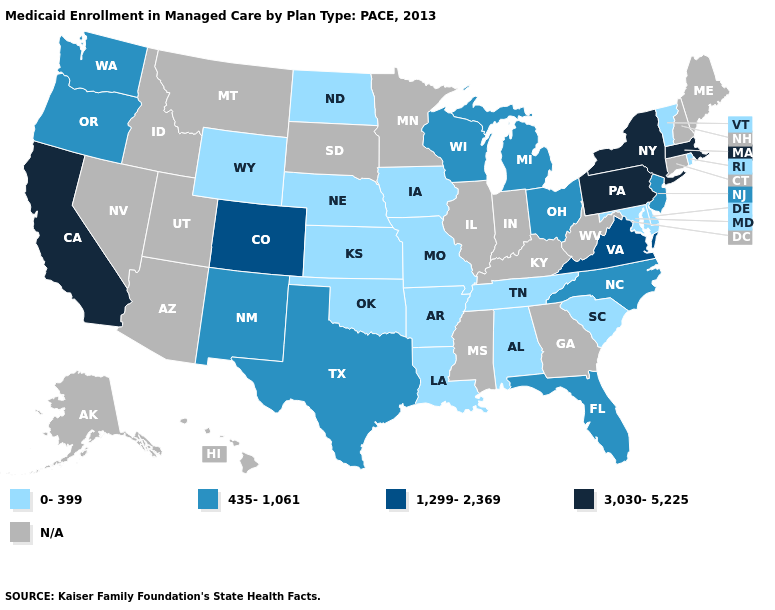Does Arkansas have the lowest value in the USA?
Short answer required. Yes. Name the states that have a value in the range 435-1,061?
Keep it brief. Florida, Michigan, New Jersey, New Mexico, North Carolina, Ohio, Oregon, Texas, Washington, Wisconsin. What is the highest value in the USA?
Write a very short answer. 3,030-5,225. Does Washington have the lowest value in the USA?
Give a very brief answer. No. What is the value of Mississippi?
Be succinct. N/A. Name the states that have a value in the range N/A?
Concise answer only. Alaska, Arizona, Connecticut, Georgia, Hawaii, Idaho, Illinois, Indiana, Kentucky, Maine, Minnesota, Mississippi, Montana, Nevada, New Hampshire, South Dakota, Utah, West Virginia. What is the lowest value in states that border New Mexico?
Write a very short answer. 0-399. Which states have the lowest value in the West?
Short answer required. Wyoming. What is the highest value in states that border Nevada?
Give a very brief answer. 3,030-5,225. Does the first symbol in the legend represent the smallest category?
Keep it brief. Yes. Does New York have the lowest value in the USA?
Quick response, please. No. Which states have the highest value in the USA?
Short answer required. California, Massachusetts, New York, Pennsylvania. What is the highest value in the South ?
Quick response, please. 1,299-2,369. Is the legend a continuous bar?
Answer briefly. No. 